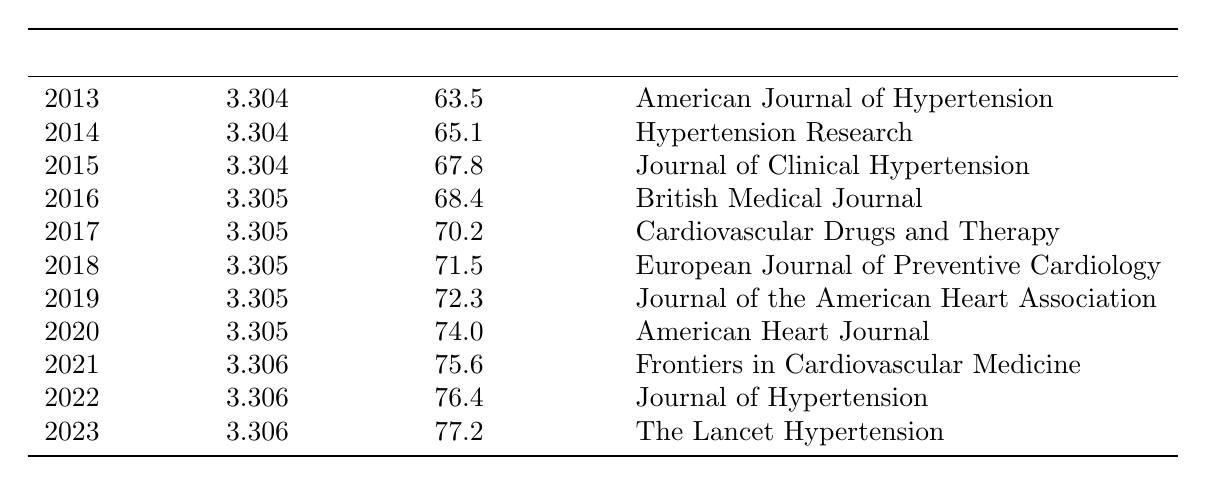What is the medication adherence rate for hypertensive patients in 2013? According to the table, the adherence rate for the year 2013 is directly listed as 63.5%.
Answer: 63.5% Which study source reported the highest adherence rate in this table? By reviewing the adherence rates listed year by year, we find that the highest rate is 77.2% in 2023, which is reported by The Lancet Hypertension.
Answer: The Lancet Hypertension What was the difference in adherence rates between 2015 and 2022? The adherence rate in 2015 is 67.8% and in 2022 it is 76.4%. Calculating the difference gives us 76.4% - 67.8% = 8.6%.
Answer: 8.6% Is the medication adherence rate consistently increasing from 2013 to 2023? Reviewing the data from the table, the adherence rates show an upward trend from 63.5% in 2013 to 77.2% in 2023, confirming that the rates are consistently increasing.
Answer: Yes What is the average medication adherence rate over the past decade? To find the average, we add all the adherence rates (63.5 + 65.1 + 67.8 + 68.4 + 70.2 + 71.5 + 72.3 + 74.0 + 75.6 + 76.4 + 77.2 =  78.0) and divide by the number of years (11), which gives us 78.0 / 11 = 70.73%.
Answer: 70.73% Which year saw the largest increase in adherence rate compared to the previous year? By comparing year to year, the largest increase occurs between 2021 (75.6%) and 2022 (76.4%), which is a change of 0.8%. We can verify this by looking at the differences between other consecutive years.
Answer: 0.8% between 2021 and 2022 Was the adherence rate in 2020 higher than that in 2019? The table indicates that the adherence rate in 2020 is 74.0%, while in 2019 it is 72.3%. Since 74.0% is greater than 72.3%, the statement is true.
Answer: Yes How many studies provided adherence rates for the years listed? Counting each study source from the table, there are 11 different studies listed, with each corresponding to a specific year.
Answer: 11 